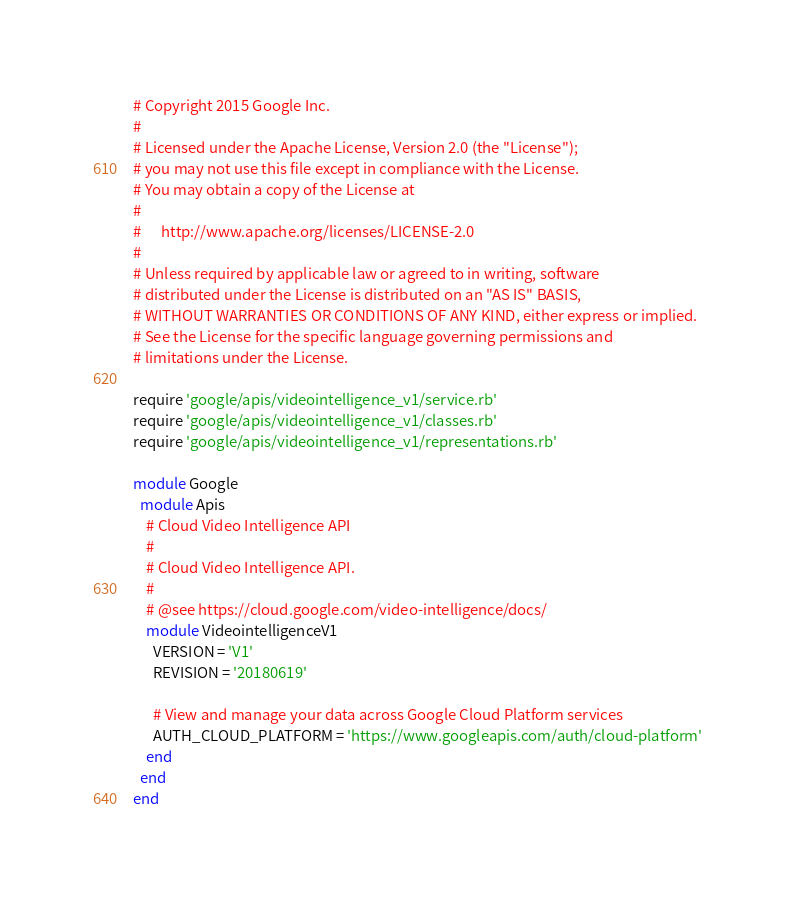Convert code to text. <code><loc_0><loc_0><loc_500><loc_500><_Ruby_># Copyright 2015 Google Inc.
#
# Licensed under the Apache License, Version 2.0 (the "License");
# you may not use this file except in compliance with the License.
# You may obtain a copy of the License at
#
#      http://www.apache.org/licenses/LICENSE-2.0
#
# Unless required by applicable law or agreed to in writing, software
# distributed under the License is distributed on an "AS IS" BASIS,
# WITHOUT WARRANTIES OR CONDITIONS OF ANY KIND, either express or implied.
# See the License for the specific language governing permissions and
# limitations under the License.

require 'google/apis/videointelligence_v1/service.rb'
require 'google/apis/videointelligence_v1/classes.rb'
require 'google/apis/videointelligence_v1/representations.rb'

module Google
  module Apis
    # Cloud Video Intelligence API
    #
    # Cloud Video Intelligence API.
    #
    # @see https://cloud.google.com/video-intelligence/docs/
    module VideointelligenceV1
      VERSION = 'V1'
      REVISION = '20180619'

      # View and manage your data across Google Cloud Platform services
      AUTH_CLOUD_PLATFORM = 'https://www.googleapis.com/auth/cloud-platform'
    end
  end
end
</code> 